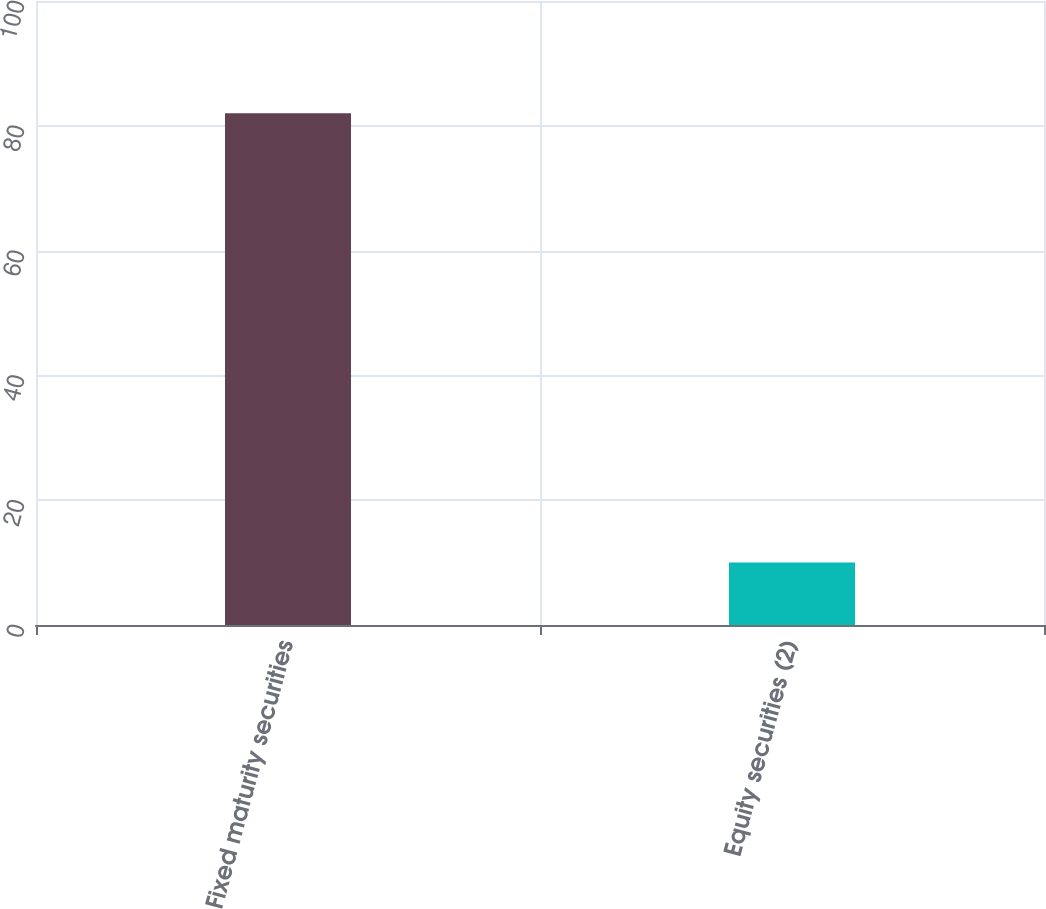<chart> <loc_0><loc_0><loc_500><loc_500><bar_chart><fcel>Fixed maturity securities<fcel>Equity securities (2)<nl><fcel>82<fcel>10<nl></chart> 